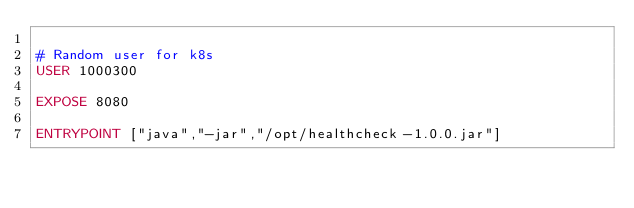<code> <loc_0><loc_0><loc_500><loc_500><_Dockerfile_>
# Random user for k8s
USER 1000300

EXPOSE 8080

ENTRYPOINT ["java","-jar","/opt/healthcheck-1.0.0.jar"]
</code> 